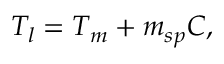Convert formula to latex. <formula><loc_0><loc_0><loc_500><loc_500>T _ { l } = T _ { m } + m _ { s p } C ,</formula> 